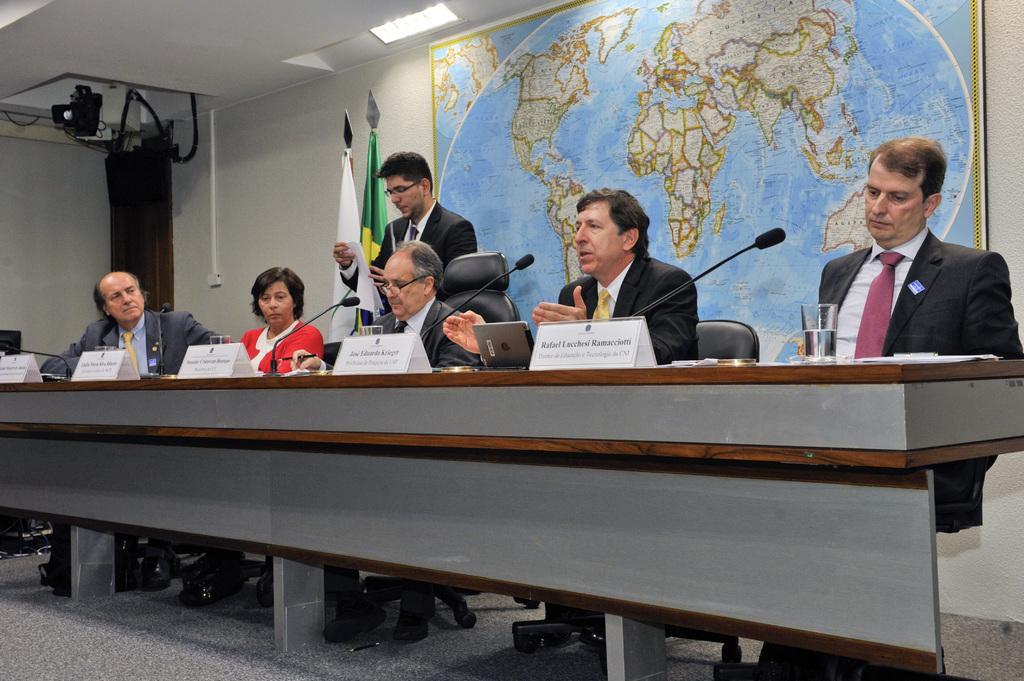Describe this image in one or two sentences. In this picture the few people sitting on chairs at the table. On the table there are glasses, name boards, laptops and papers. Behind them there is another man standing and holding papers in his hand. On the wall there is a big frame of the globe. In the background there are two flags, wall and a door. There are lights to the ceiling. 